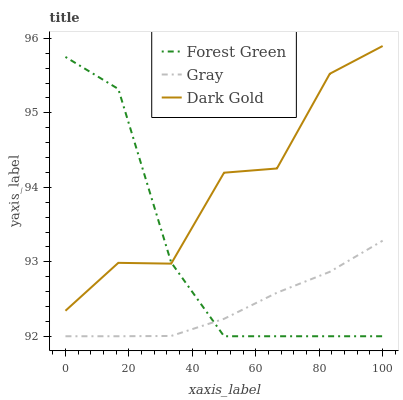Does Gray have the minimum area under the curve?
Answer yes or no. Yes. Does Dark Gold have the maximum area under the curve?
Answer yes or no. Yes. Does Forest Green have the minimum area under the curve?
Answer yes or no. No. Does Forest Green have the maximum area under the curve?
Answer yes or no. No. Is Gray the smoothest?
Answer yes or no. Yes. Is Dark Gold the roughest?
Answer yes or no. Yes. Is Forest Green the smoothest?
Answer yes or no. No. Is Forest Green the roughest?
Answer yes or no. No. Does Gray have the lowest value?
Answer yes or no. Yes. Does Dark Gold have the lowest value?
Answer yes or no. No. Does Dark Gold have the highest value?
Answer yes or no. Yes. Does Forest Green have the highest value?
Answer yes or no. No. Is Gray less than Dark Gold?
Answer yes or no. Yes. Is Dark Gold greater than Gray?
Answer yes or no. Yes. Does Forest Green intersect Gray?
Answer yes or no. Yes. Is Forest Green less than Gray?
Answer yes or no. No. Is Forest Green greater than Gray?
Answer yes or no. No. Does Gray intersect Dark Gold?
Answer yes or no. No. 